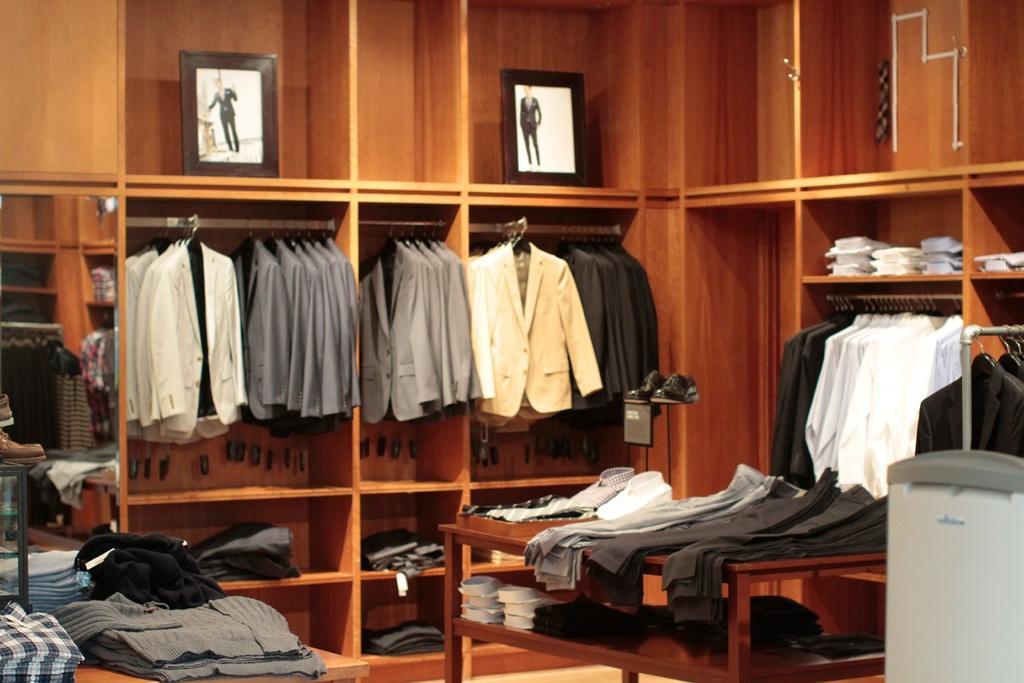In one or two sentences, can you explain what this image depicts? In this picture, we see suits and blazers are hanged to the hangers. Beside that, we see a cupboard in which many shirts are hanged. In the middle of the picture, we see a table on which clothes in white, grey and black color are placed. In the left bottom of the picture, we see a table on which clothes are placed. At the top of the picture, we see two photo frames are placed in the rack. This picture might be clicked in the textile shop. 